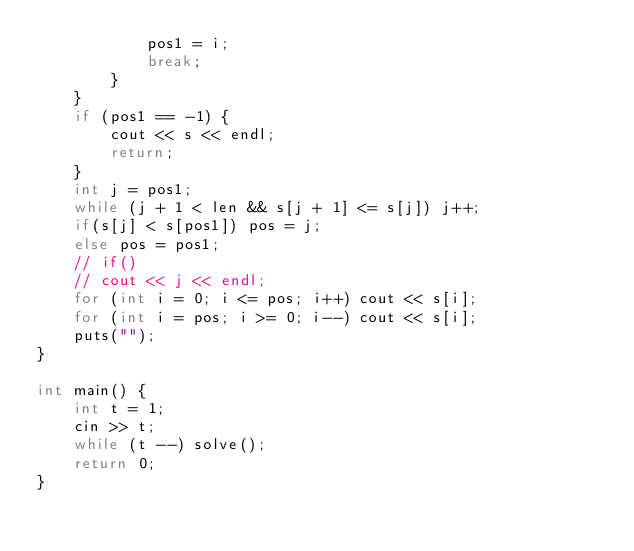<code> <loc_0><loc_0><loc_500><loc_500><_C++_>            pos1 = i;
            break;
        }
    }
    if (pos1 == -1) {
        cout << s << endl;
        return;
    }
    int j = pos1;
    while (j + 1 < len && s[j + 1] <= s[j]) j++;
    if(s[j] < s[pos1]) pos = j;
    else pos = pos1;
    // if()
    // cout << j << endl;
    for (int i = 0; i <= pos; i++) cout << s[i];
    for (int i = pos; i >= 0; i--) cout << s[i];
    puts("");
}

int main() {
    int t = 1;
    cin >> t;
    while (t --) solve();
    return 0;
}</code> 